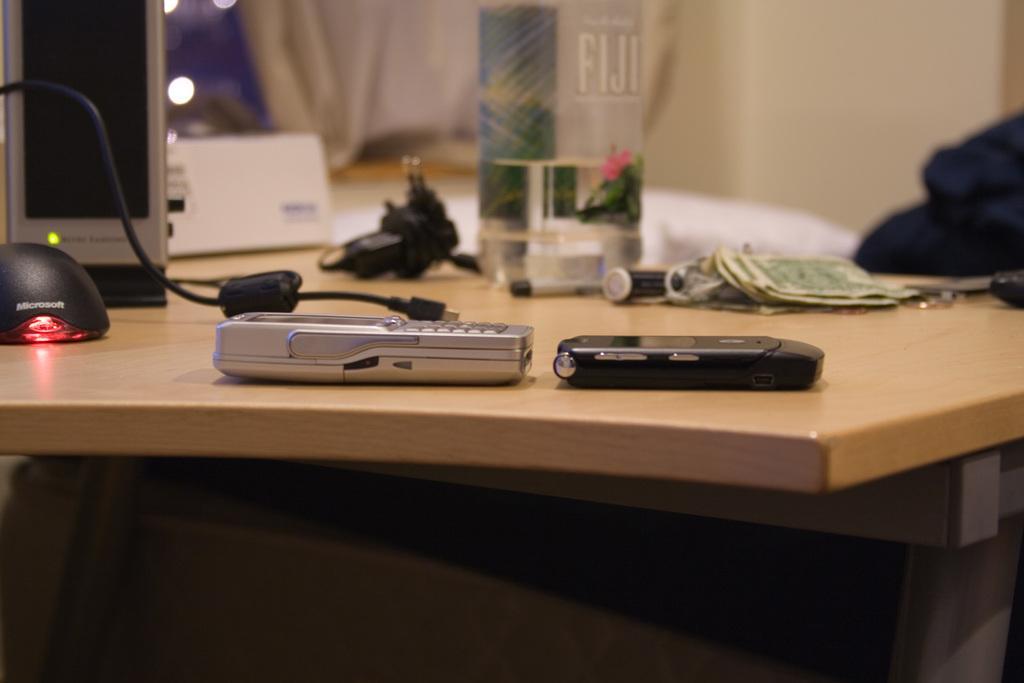Describe this image in one or two sentences. In this image there are mobile phones , money , batteries,bottle, cables, mouse , cloth arranged on a table ,and in the back ground there is a wall. 